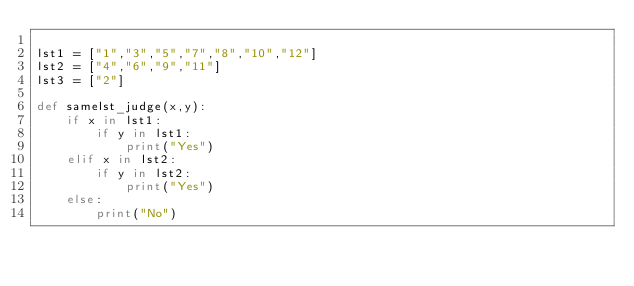<code> <loc_0><loc_0><loc_500><loc_500><_Python_>
lst1 = ["1","3","5","7","8","10","12"]
lst2 = ["4","6","9","11"]
lst3 = ["2"]

def samelst_judge(x,y):
    if x in lst1:
        if y in lst1:
            print("Yes")
    elif x in lst2:
        if y in lst2:
            print("Yes")
    else:
        print("No")</code> 